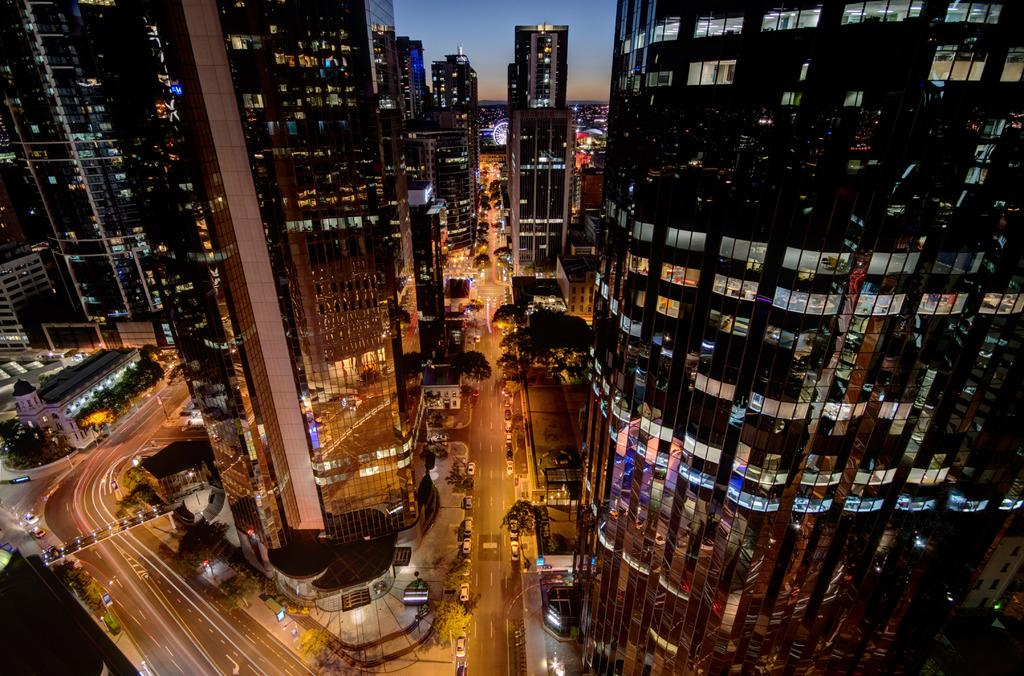At what time of day was the image taken? The image was taken during night time. What types of structures can be seen in the image? There are buildings and a bridge in the image. What type of vegetation is present in the image? There are trees in the image. What mode of transportation can be seen in the image? There are vehicles on the road in the image. What part of the natural environment is visible in the image? The sky is visible in the image. Can you see any wings on the vehicles in the image? There are no wings visible on the vehicles in the image. What type of boat is present in the image? There is no boat present in the image. 